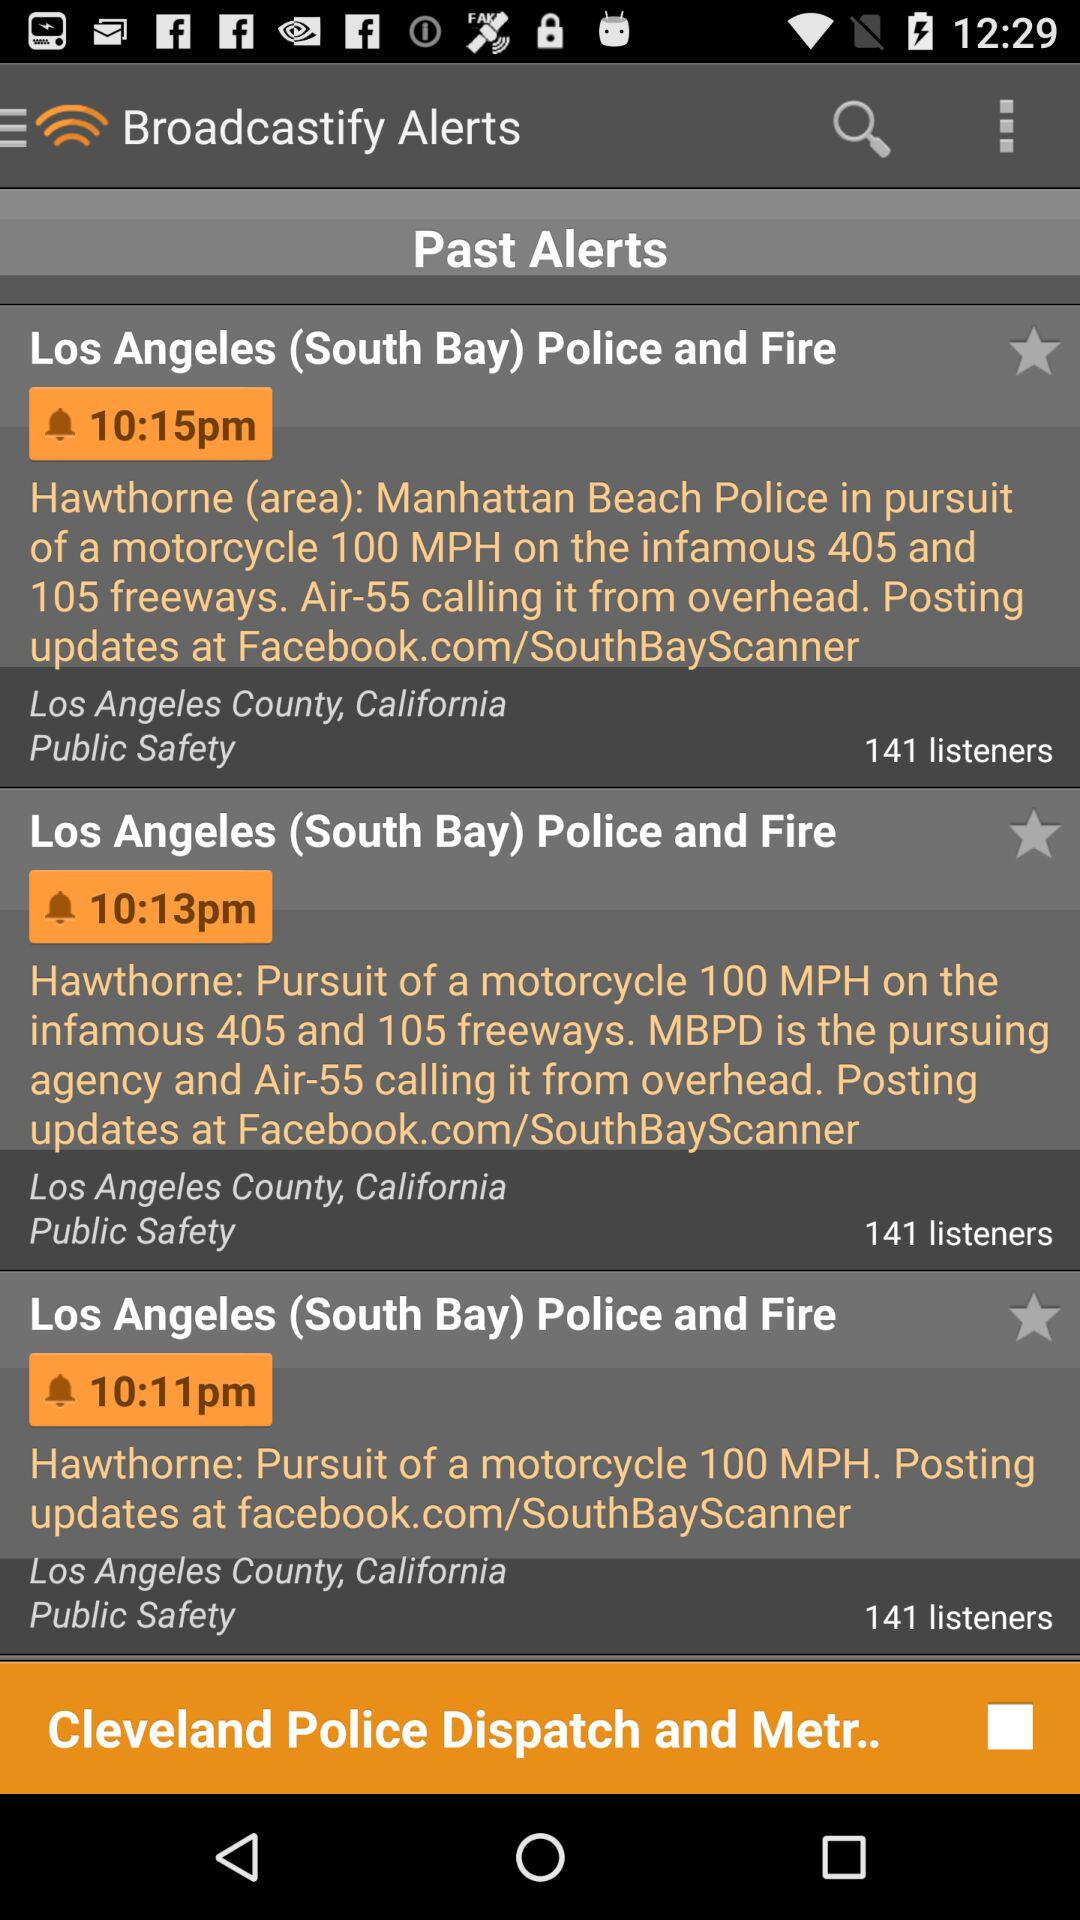What is the number of listeners to the alert broadcast at 10:15 p.m.? The number of listeners is 141. 